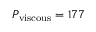<formula> <loc_0><loc_0><loc_500><loc_500>P _ { v i s c o u s } = 1 7 7</formula> 